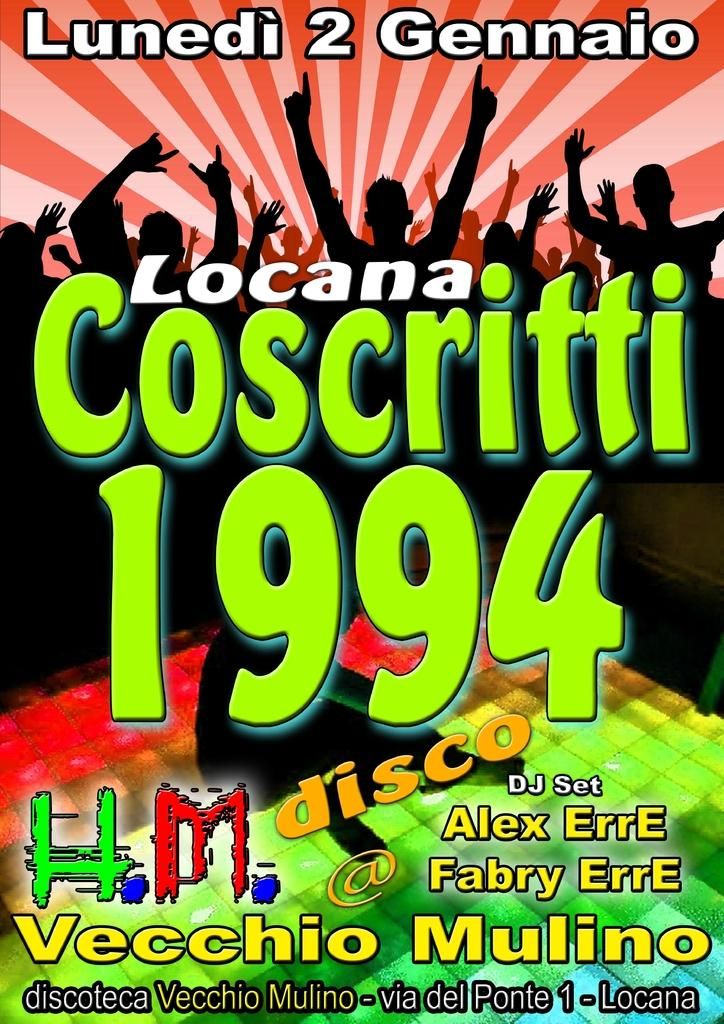<image>
Give a short and clear explanation of the subsequent image. Poster showing the word Coscritti and year 1994 in green. 